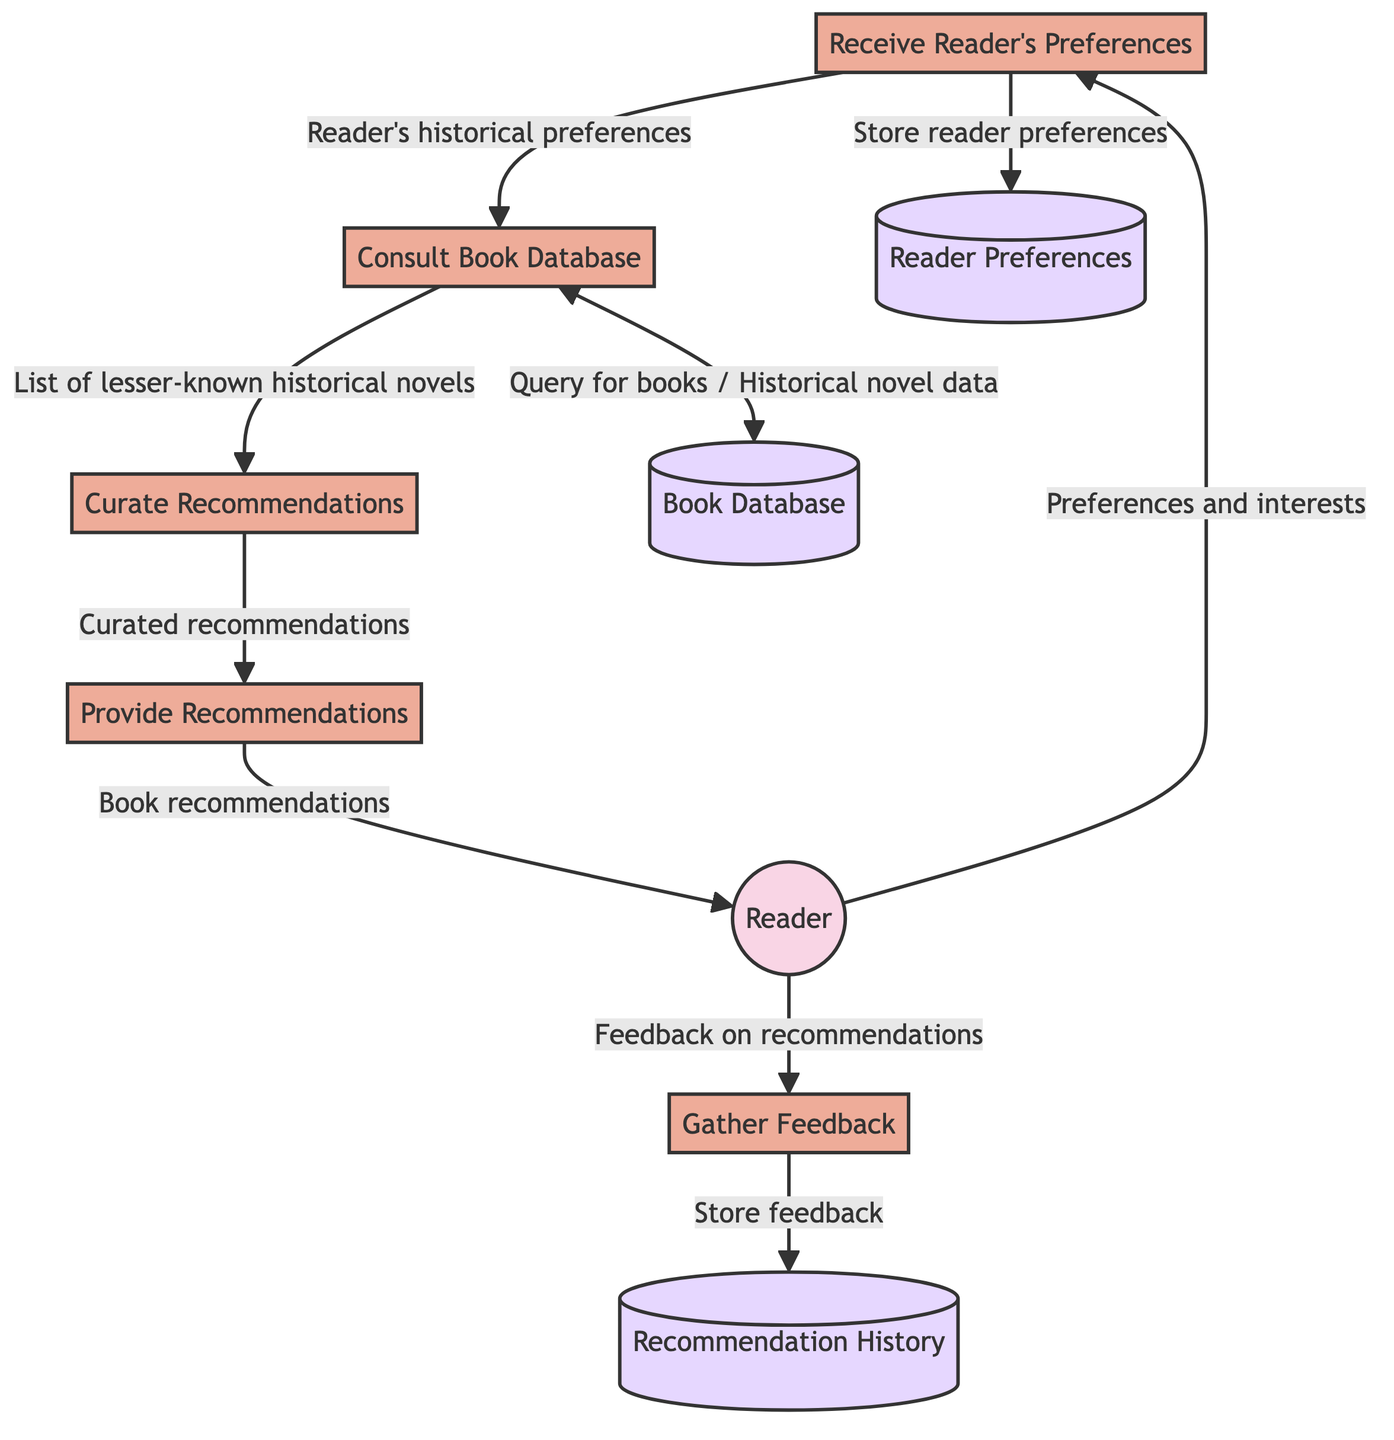What external entity is shown in the diagram? The diagram includes one external entity, which is the Reader, defined as a book lover seeking novel recommendations.
Answer: Reader How many processes are represented in the diagram? There are five processes represented, which are receiving preferences, consulting the book database, curating recommendations, providing recommendations, and gathering feedback.
Answer: 5 What is stored in the data store labeled "D1"? The data store labeled "D1" is designated for storing data about individual readers' historical novel preferences.
Answer: Reader Preferences Which process delivers book recommendations to the reader? The process that delivers book recommendations to the reader is labeled as "Provide Recommendations".
Answer: Provide Recommendations What feedback does the reader provide in the diagram? The reader provides feedback on the recommendations they received, which is collected by the "Gather Feedback" process.
Answer: Feedback on recommendations Which data store does the process "Consult Book Database" query for books? The process "Consult Book Database" queries the data store labeled "D2" to obtain information related to historical novels.
Answer: Book Database In which order does the "Gather Feedback" process interact with the reader and data store? The "Gather Feedback" process first receives feedback from the reader and then stores it in the data store labeled "D3".
Answer: First with the reader, then with D3 What type of data flows from the Reader to the "Receive Reader's Preferences" process? The data flowing from the Reader to the "Receive Reader's Preferences" process is described as "Preferences and interests".
Answer: Preferences and interests How does the "Curate Recommendations" process receive input? The "Curate Recommendations" process receives input in the form of a list of lesser-known historical novels, which comes from the "Consult Book Database" process.
Answer: List of lesser-known historical novels 